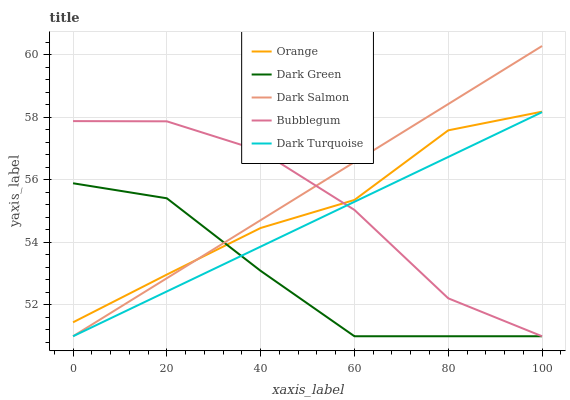Does Dark Green have the minimum area under the curve?
Answer yes or no. Yes. Does Dark Salmon have the maximum area under the curve?
Answer yes or no. Yes. Does Dark Turquoise have the minimum area under the curve?
Answer yes or no. No. Does Dark Turquoise have the maximum area under the curve?
Answer yes or no. No. Is Dark Salmon the smoothest?
Answer yes or no. Yes. Is Bubblegum the roughest?
Answer yes or no. Yes. Is Dark Turquoise the smoothest?
Answer yes or no. No. Is Dark Turquoise the roughest?
Answer yes or no. No. Does Dark Turquoise have the lowest value?
Answer yes or no. Yes. Does Dark Salmon have the highest value?
Answer yes or no. Yes. Does Dark Turquoise have the highest value?
Answer yes or no. No. Is Dark Turquoise less than Orange?
Answer yes or no. Yes. Is Orange greater than Dark Turquoise?
Answer yes or no. Yes. Does Bubblegum intersect Dark Salmon?
Answer yes or no. Yes. Is Bubblegum less than Dark Salmon?
Answer yes or no. No. Is Bubblegum greater than Dark Salmon?
Answer yes or no. No. Does Dark Turquoise intersect Orange?
Answer yes or no. No. 